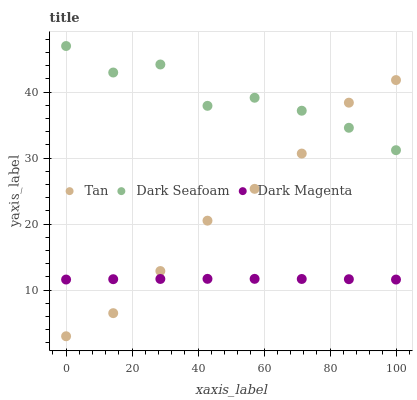Does Dark Magenta have the minimum area under the curve?
Answer yes or no. Yes. Does Dark Seafoam have the maximum area under the curve?
Answer yes or no. Yes. Does Dark Seafoam have the minimum area under the curve?
Answer yes or no. No. Does Dark Magenta have the maximum area under the curve?
Answer yes or no. No. Is Dark Magenta the smoothest?
Answer yes or no. Yes. Is Dark Seafoam the roughest?
Answer yes or no. Yes. Is Dark Seafoam the smoothest?
Answer yes or no. No. Is Dark Magenta the roughest?
Answer yes or no. No. Does Tan have the lowest value?
Answer yes or no. Yes. Does Dark Magenta have the lowest value?
Answer yes or no. No. Does Dark Seafoam have the highest value?
Answer yes or no. Yes. Does Dark Magenta have the highest value?
Answer yes or no. No. Is Dark Magenta less than Dark Seafoam?
Answer yes or no. Yes. Is Dark Seafoam greater than Dark Magenta?
Answer yes or no. Yes. Does Dark Seafoam intersect Tan?
Answer yes or no. Yes. Is Dark Seafoam less than Tan?
Answer yes or no. No. Is Dark Seafoam greater than Tan?
Answer yes or no. No. Does Dark Magenta intersect Dark Seafoam?
Answer yes or no. No. 